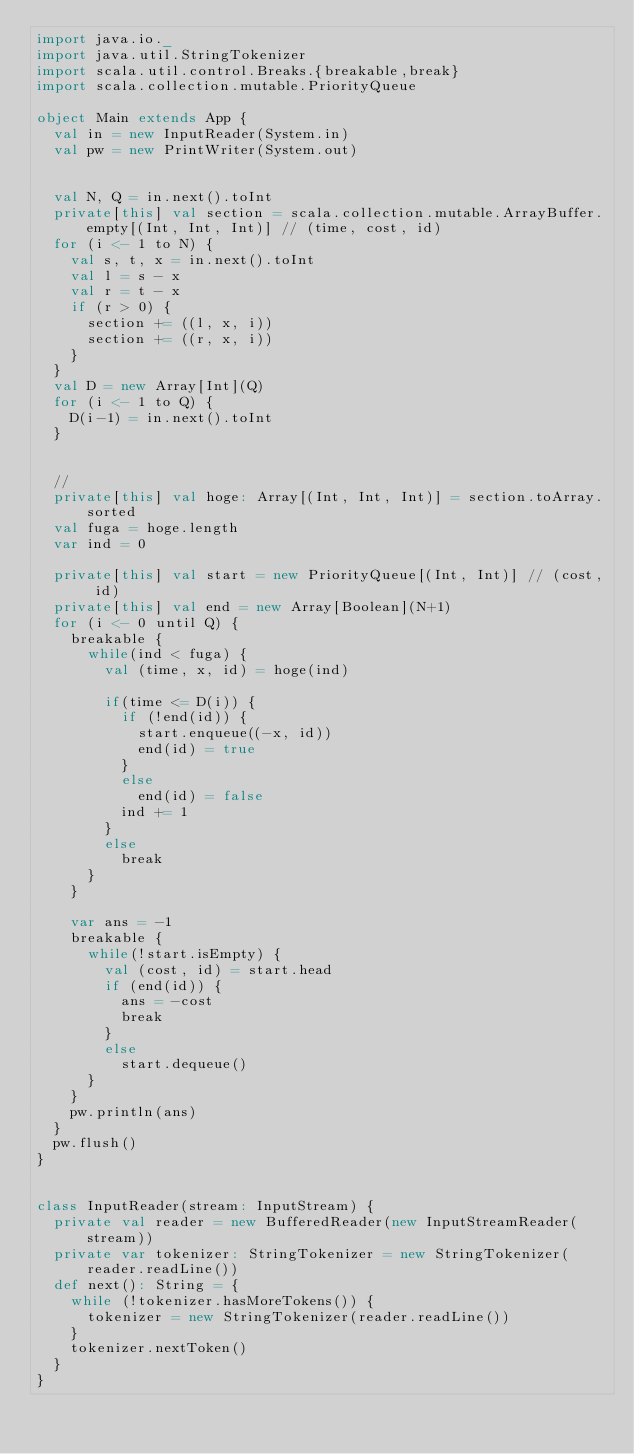<code> <loc_0><loc_0><loc_500><loc_500><_Scala_>import java.io._
import java.util.StringTokenizer
import scala.util.control.Breaks.{breakable,break}
import scala.collection.mutable.PriorityQueue

object Main extends App {
  val in = new InputReader(System.in)
  val pw = new PrintWriter(System.out)


  val N, Q = in.next().toInt
  private[this] val section = scala.collection.mutable.ArrayBuffer.empty[(Int, Int, Int)] // (time, cost, id)
  for (i <- 1 to N) {
    val s, t, x = in.next().toInt
    val l = s - x
    val r = t - x
    if (r > 0) {
      section += ((l, x, i))
      section += ((r, x, i))
    }
  }
  val D = new Array[Int](Q)
  for (i <- 1 to Q) {
    D(i-1) = in.next().toInt
  }


  //
  private[this] val hoge: Array[(Int, Int, Int)] = section.toArray.sorted
  val fuga = hoge.length
  var ind = 0

  private[this] val start = new PriorityQueue[(Int, Int)] // (cost, id)
  private[this] val end = new Array[Boolean](N+1)
  for (i <- 0 until Q) {
    breakable {
      while(ind < fuga) {
        val (time, x, id) = hoge(ind)

        if(time <= D(i)) {
          if (!end(id)) {
            start.enqueue((-x, id))
            end(id) = true
          }
          else
            end(id) = false
          ind += 1
        }
        else
          break
      }
    }

    var ans = -1
    breakable {
      while(!start.isEmpty) {
        val (cost, id) = start.head
        if (end(id)) {
          ans = -cost
          break
        }
        else
          start.dequeue()
      }
    }
    pw.println(ans)
  }
  pw.flush()
}


class InputReader(stream: InputStream) {
  private val reader = new BufferedReader(new InputStreamReader(stream))
  private var tokenizer: StringTokenizer = new StringTokenizer(reader.readLine())
  def next(): String = {
    while (!tokenizer.hasMoreTokens()) {
      tokenizer = new StringTokenizer(reader.readLine())
    }
    tokenizer.nextToken()
  }
}
</code> 